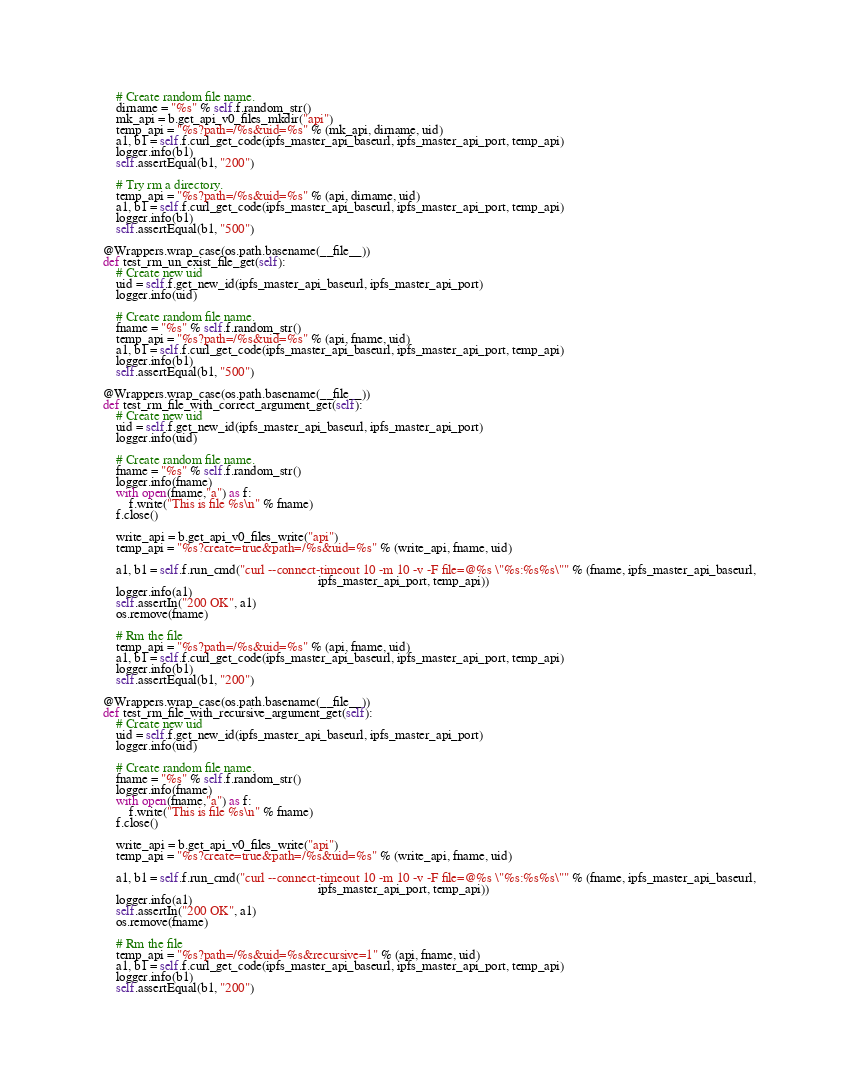<code> <loc_0><loc_0><loc_500><loc_500><_Python_>
        # Create random file name.
        dirname = "%s" % self.f.random_str()
        mk_api = b.get_api_v0_files_mkdir("api")
        temp_api = "%s?path=/%s&uid=%s" % (mk_api, dirname, uid)
        a1, b1 = self.f.curl_get_code(ipfs_master_api_baseurl, ipfs_master_api_port, temp_api)
        logger.info(b1)
        self.assertEqual(b1, "200")

        # Try rm a directory.
        temp_api = "%s?path=/%s&uid=%s" % (api, dirname, uid)
        a1, b1 = self.f.curl_get_code(ipfs_master_api_baseurl, ipfs_master_api_port, temp_api)
        logger.info(b1)
        self.assertEqual(b1, "500")

    @Wrappers.wrap_case(os.path.basename(__file__))
    def test_rm_un_exist_file_get(self):
        # Create new uid
        uid = self.f.get_new_id(ipfs_master_api_baseurl, ipfs_master_api_port)
        logger.info(uid)

        # Create random file name.
        fname = "%s" % self.f.random_str()
        temp_api = "%s?path=/%s&uid=%s" % (api, fname, uid)
        a1, b1 = self.f.curl_get_code(ipfs_master_api_baseurl, ipfs_master_api_port, temp_api)
        logger.info(b1)
        self.assertEqual(b1, "500")

    @Wrappers.wrap_case(os.path.basename(__file__))
    def test_rm_file_with_correct_argument_get(self):
        # Create new uid
        uid = self.f.get_new_id(ipfs_master_api_baseurl, ipfs_master_api_port)
        logger.info(uid)

        # Create random file name.
        fname = "%s" % self.f.random_str()
        logger.info(fname)
        with open(fname,"a") as f:
            f.write("This is file %s\n" % fname)
        f.close()

        write_api = b.get_api_v0_files_write("api")
        temp_api = "%s?create=true&path=/%s&uid=%s" % (write_api, fname, uid)

        a1, b1 = self.f.run_cmd("curl --connect-timeout 10 -m 10 -v -F file=@%s \"%s:%s%s\"" % (fname, ipfs_master_api_baseurl,
                                                                      ipfs_master_api_port, temp_api))
        logger.info(a1)
        self.assertIn("200 OK", a1)
        os.remove(fname)

        # Rm the file
        temp_api = "%s?path=/%s&uid=%s" % (api, fname, uid)
        a1, b1 = self.f.curl_get_code(ipfs_master_api_baseurl, ipfs_master_api_port, temp_api)
        logger.info(b1)
        self.assertEqual(b1, "200")

    @Wrappers.wrap_case(os.path.basename(__file__))
    def test_rm_file_with_recursive_argument_get(self):
        # Create new uid
        uid = self.f.get_new_id(ipfs_master_api_baseurl, ipfs_master_api_port)
        logger.info(uid)

        # Create random file name.
        fname = "%s" % self.f.random_str()
        logger.info(fname)
        with open(fname,"a") as f:
            f.write("This is file %s\n" % fname)
        f.close()

        write_api = b.get_api_v0_files_write("api")
        temp_api = "%s?create=true&path=/%s&uid=%s" % (write_api, fname, uid)

        a1, b1 = self.f.run_cmd("curl --connect-timeout 10 -m 10 -v -F file=@%s \"%s:%s%s\"" % (fname, ipfs_master_api_baseurl,
                                                                      ipfs_master_api_port, temp_api))
        logger.info(a1)
        self.assertIn("200 OK", a1)
        os.remove(fname)

        # Rm the file
        temp_api = "%s?path=/%s&uid=%s&recursive=1" % (api, fname, uid)
        a1, b1 = self.f.curl_get_code(ipfs_master_api_baseurl, ipfs_master_api_port, temp_api)
        logger.info(b1)
        self.assertEqual(b1, "200")
</code> 